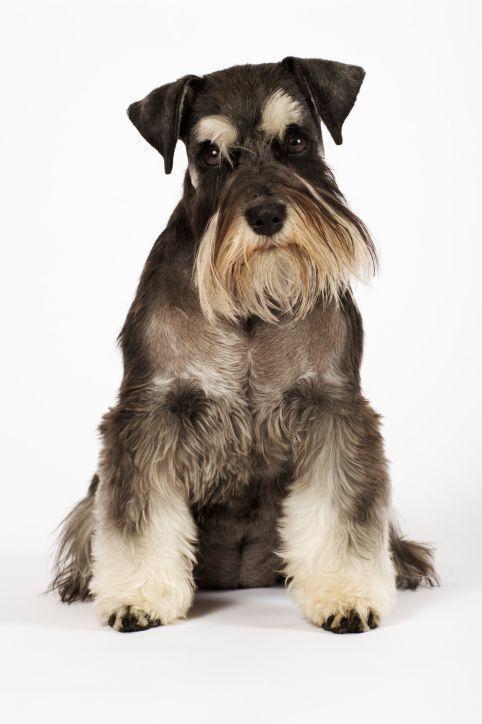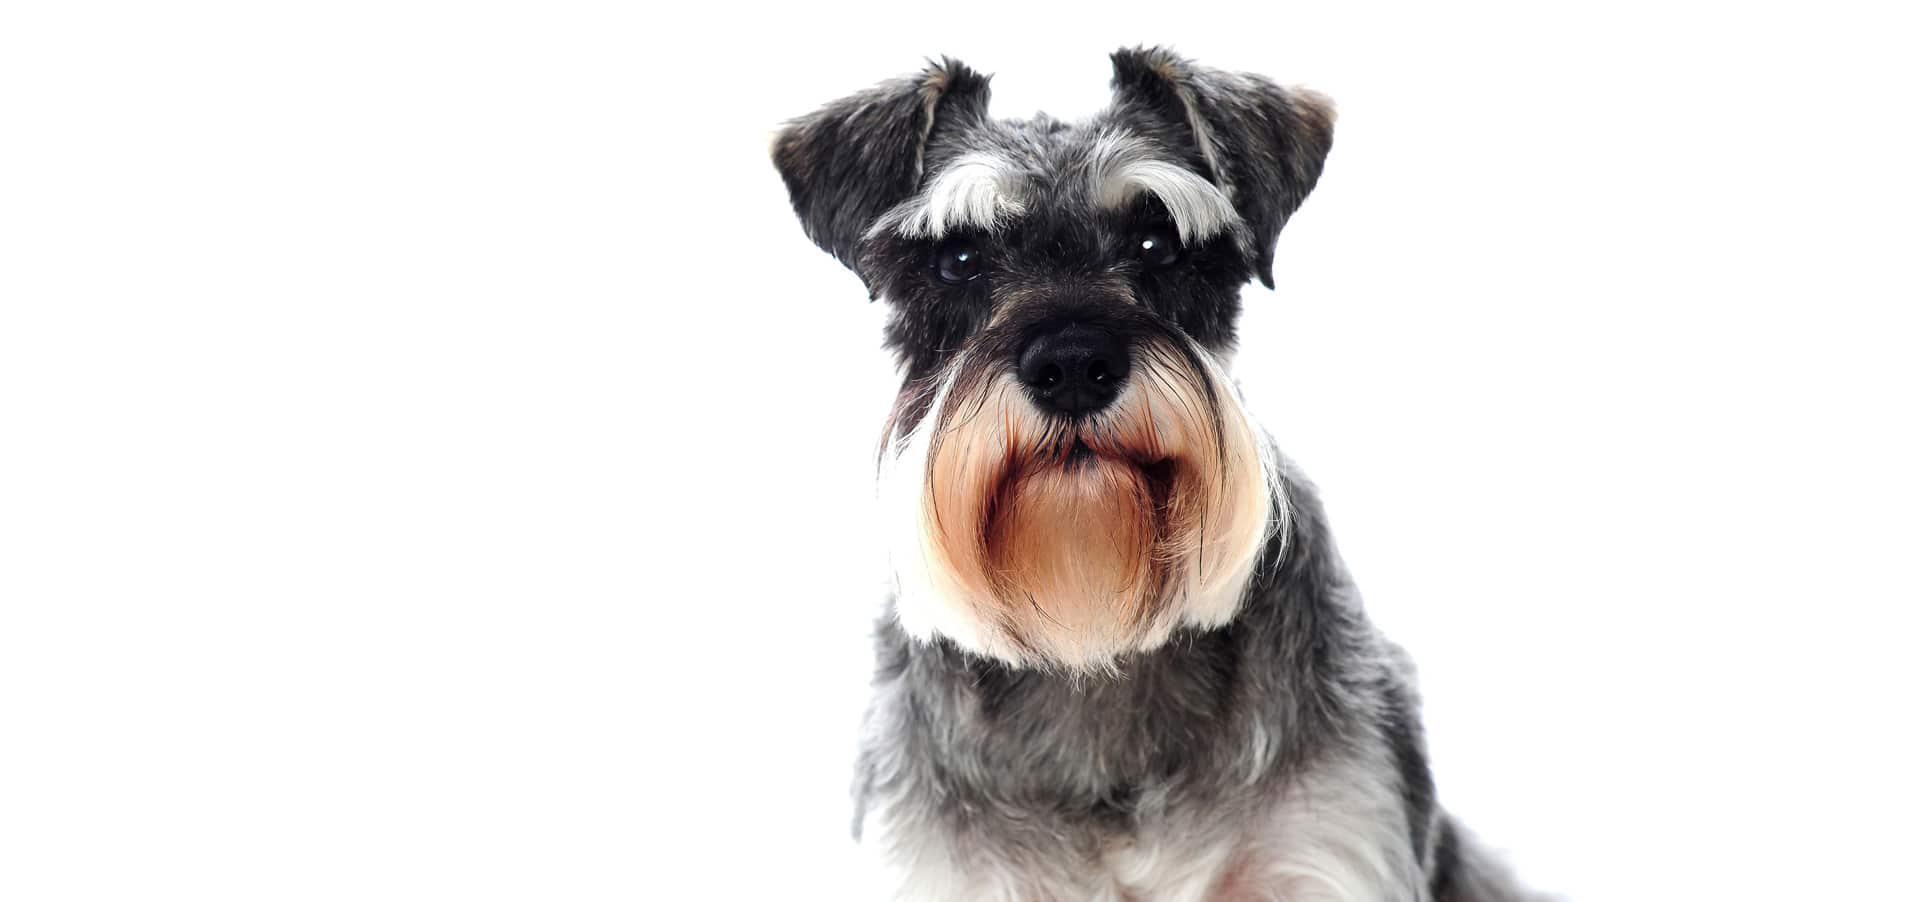The first image is the image on the left, the second image is the image on the right. For the images displayed, is the sentence "in the right pic the dog is wearing something" factually correct? Answer yes or no. No. The first image is the image on the left, the second image is the image on the right. For the images shown, is this caption "There are at least 3 dogs and 2 are sitting in these." true? Answer yes or no. No. 